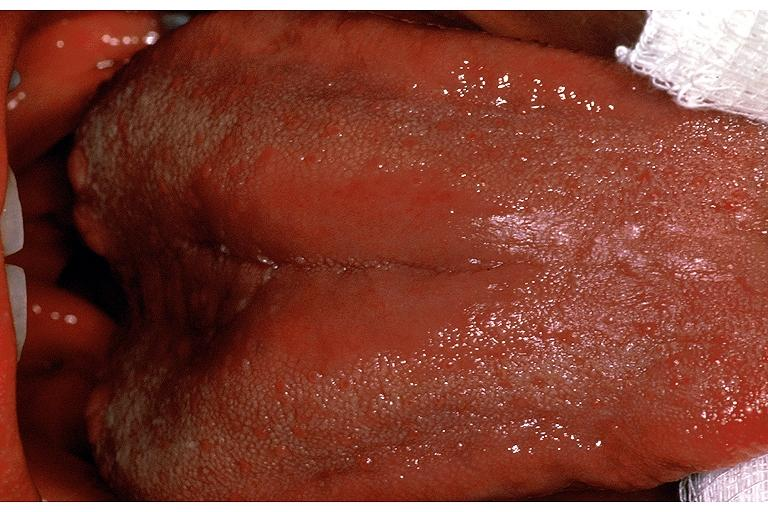s oral present?
Answer the question using a single word or phrase. Yes 